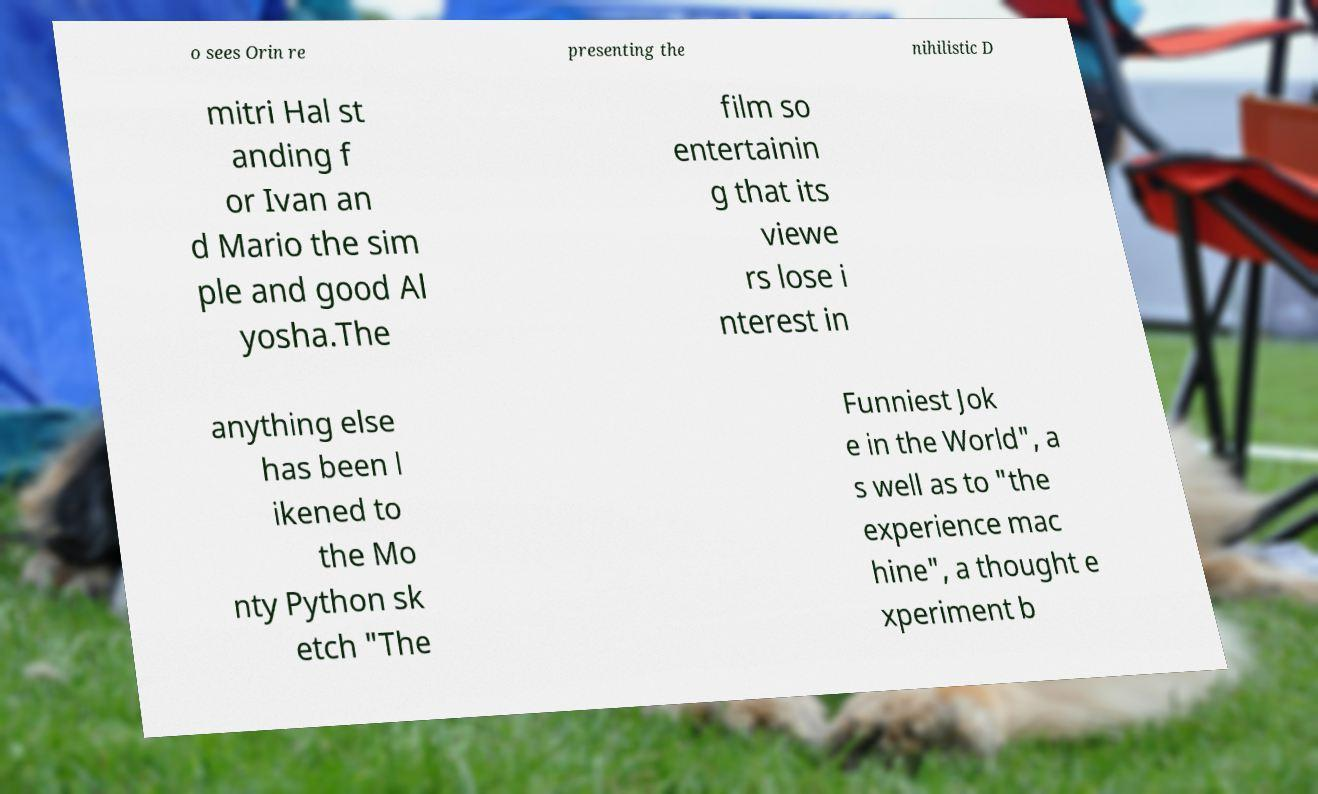Please identify and transcribe the text found in this image. o sees Orin re presenting the nihilistic D mitri Hal st anding f or Ivan an d Mario the sim ple and good Al yosha.The film so entertainin g that its viewe rs lose i nterest in anything else has been l ikened to the Mo nty Python sk etch "The Funniest Jok e in the World", a s well as to "the experience mac hine", a thought e xperiment b 